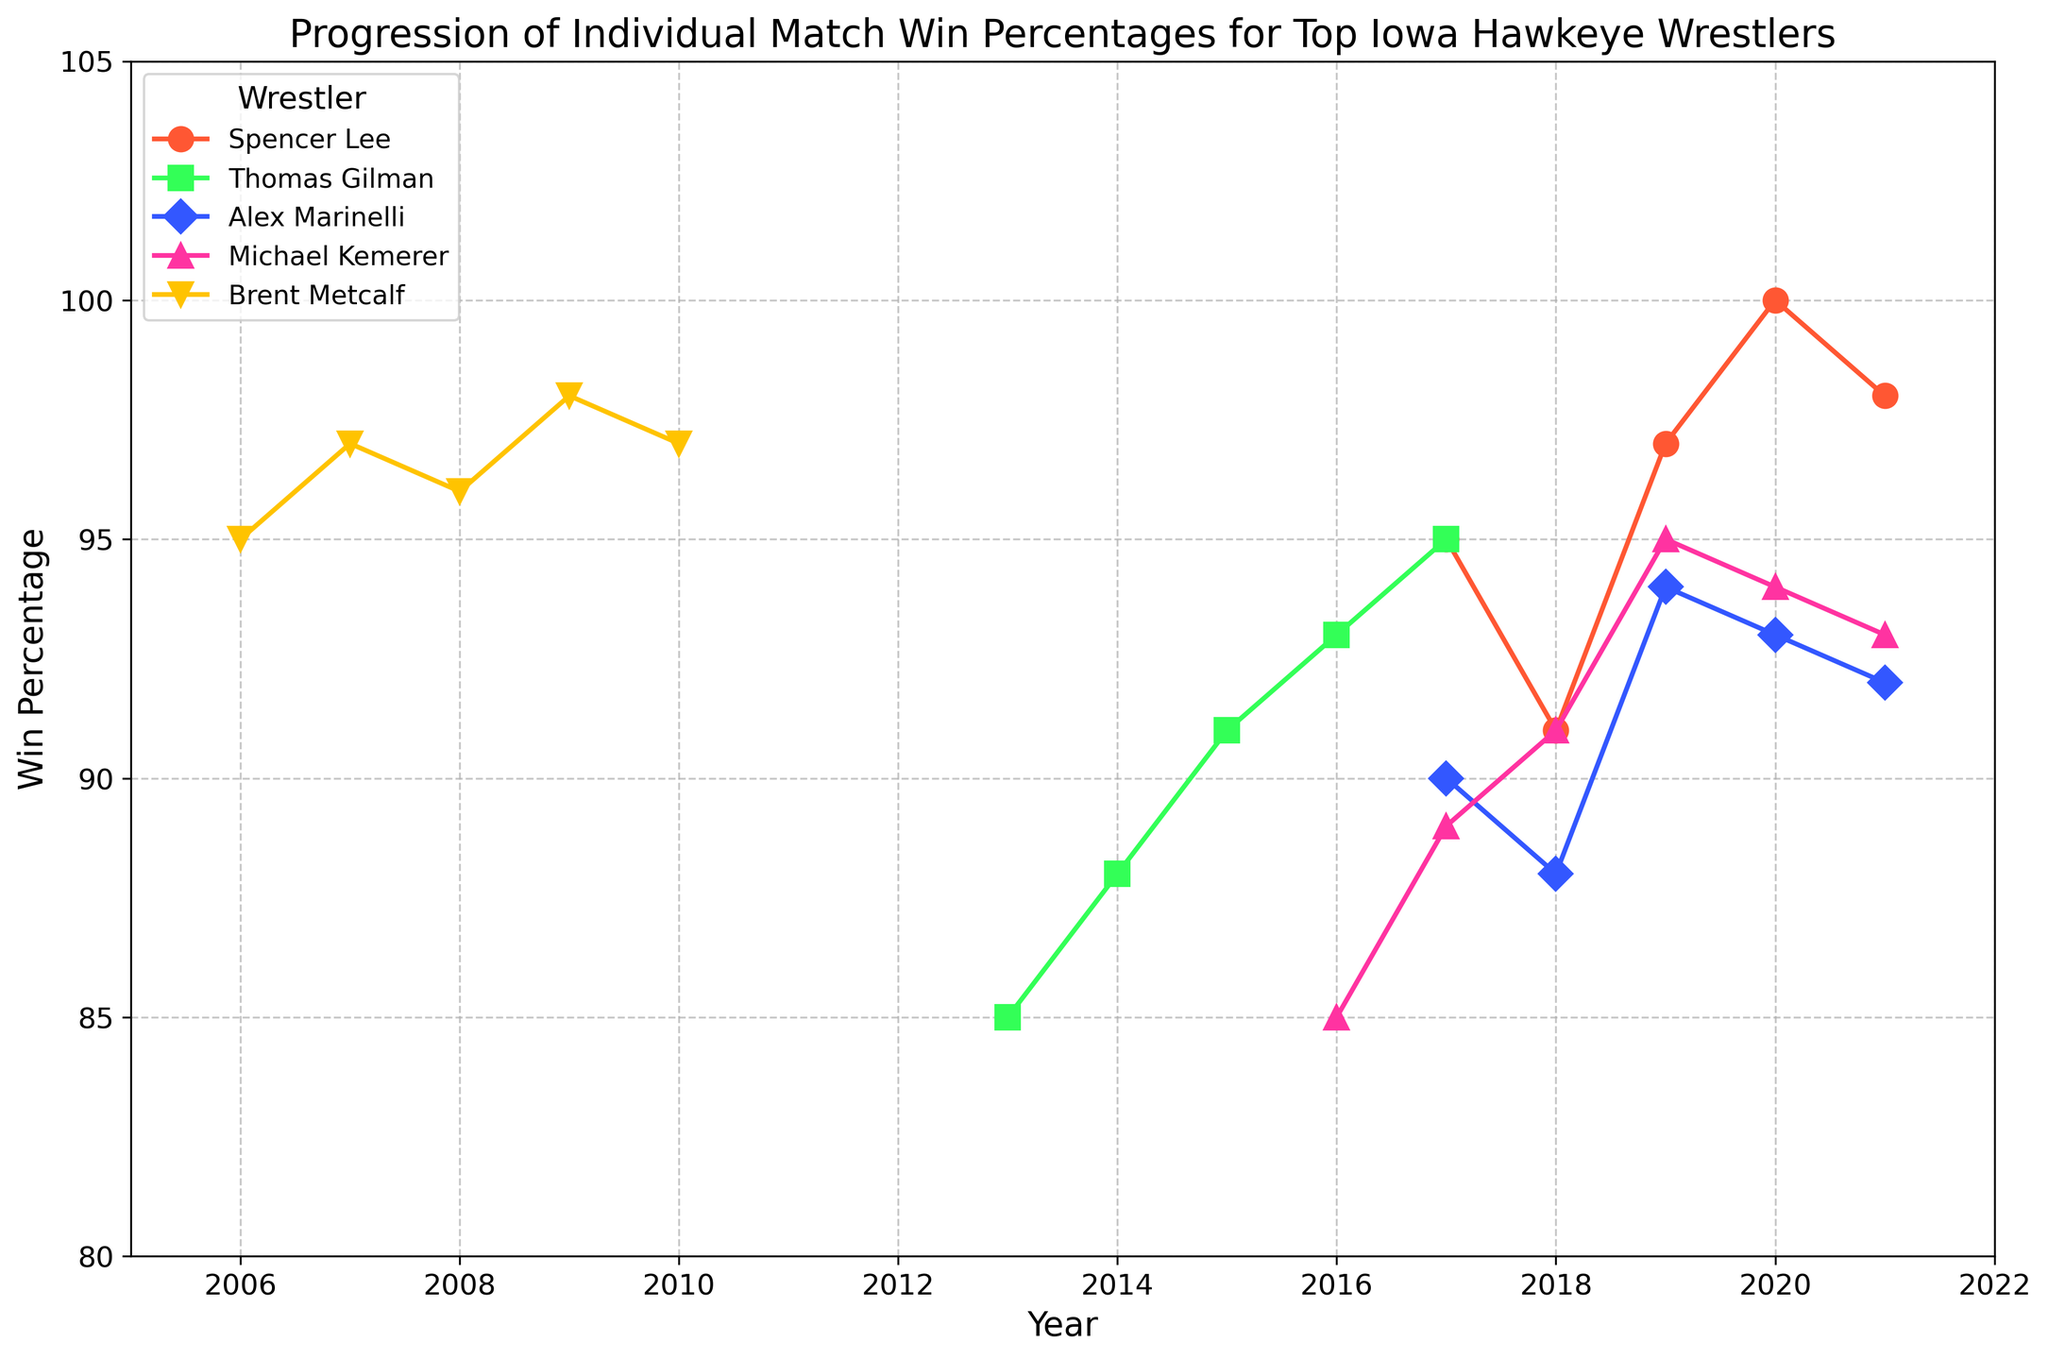What is Spencer Lee's highest win percentage, and in which year did it occur? Spencer Lee's win percentage is shown over several years. His highest win percentage is 100%, which occurred in the year 2020.
Answer: 100%, 2020 How does Brent Metcalf's win percentage in 2007 compare to that in 2009? In the plot, Brent Metcalf's win percentage in 2007 is 97%, while in 2009, it is 98%. So, it increased by 1 percentage point.
Answer: Increased by 1 percentage point Whose win percentage increased the most from their first recorded year to their last, and by how much? By evaluating the progression lines of each wrestler, we see that Brent Metcalf's win percentage started at 95% in 2006 and ended at 97% in 2010, which is a 2 percentage point increase. The largest increase belongs to Thomas Gilman, whose percentage increased from 85% in 2013 to 95% in 2017, which is a 10 percentage point increase.
Answer: Thomas Gilman, 10 percentage points Who had the lowest win percentage in their first year, and what was it? Among all the wrestlers, Thomas Gilman had the lowest win percentage in his first year (2013), which was 85%.
Answer: Thomas Gilman, 85% What is the average win percentage for Michael Kemerer over his collegiate career? To find the average win percentage for Michael Kemerer, add up his yearly win percentages (85, 89, 91, 95, 94, 93) and divide by the number of years (6). (85 + 89 + 91 + 95 + 94 + 93) / 6 = 547 / 6 = 91.17%
Answer: 91.17% Which wrestler experienced a dip in their win percentage compared to the previous year, and in which year did it occur? Spencer Lee had a win percentage dip from 2017 to 2018 (95% to 91%). Another example is Alex Marinelli, who had a dip from 2017 to 2018 (90% to 88%).
Answer: Spencer Lee (2018), Alex Marinelli (2018) Comparing the final recorded years for all wrestlers, who had the highest win percentage? The final recorded years for each wrestler show varying win percentages. Spencer Lee had the highest final recorded year win percentage at 98% in 2021.
Answer: Spencer Lee, 98% Which wrestler had the most consistent (least variable) win percentages across all years, and what indicates this consistency? Consistency can be identified by small variations in win percentages over time. Spencer Lee's win percentages are consistently high (ranging from 91% to 100%), indicating he is the most consistent among the wrestlers.
Answer: Spencer Lee What color represents Thomas Gilman's career progression on the plot, and what is its significance? Thomas Gilman's career progression in the plot is represented by a green color line. This distinct color helps differentiate his progress from other wrestlers' data.
Answer: Green By how much did Alex Marinelli's win percentage change from 2018 to 2019? Alex Marinelli's win percentages were 88% in 2018 and 94% in 2019. The change is calculated as 94% - 88% = 6 percentage points.
Answer: 6 percentage points 